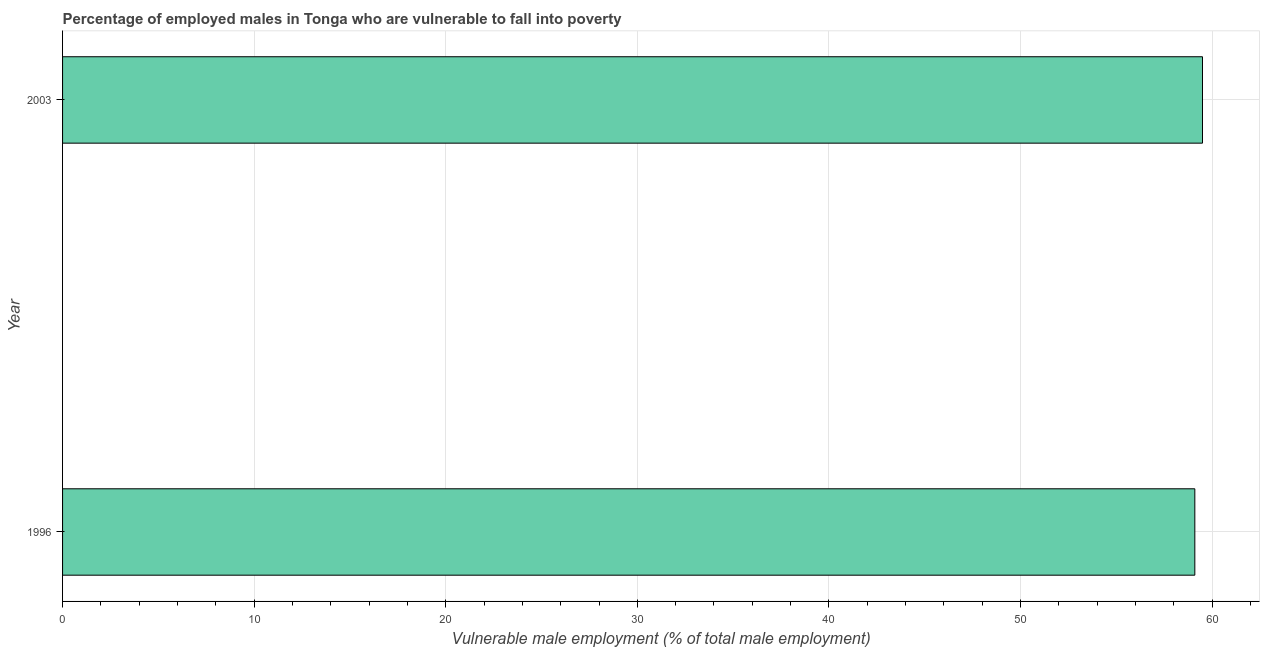Does the graph contain any zero values?
Provide a succinct answer. No. Does the graph contain grids?
Ensure brevity in your answer.  Yes. What is the title of the graph?
Make the answer very short. Percentage of employed males in Tonga who are vulnerable to fall into poverty. What is the label or title of the X-axis?
Offer a terse response. Vulnerable male employment (% of total male employment). What is the percentage of employed males who are vulnerable to fall into poverty in 2003?
Your answer should be compact. 59.5. Across all years, what is the maximum percentage of employed males who are vulnerable to fall into poverty?
Ensure brevity in your answer.  59.5. Across all years, what is the minimum percentage of employed males who are vulnerable to fall into poverty?
Provide a succinct answer. 59.1. In which year was the percentage of employed males who are vulnerable to fall into poverty maximum?
Your response must be concise. 2003. In which year was the percentage of employed males who are vulnerable to fall into poverty minimum?
Make the answer very short. 1996. What is the sum of the percentage of employed males who are vulnerable to fall into poverty?
Your response must be concise. 118.6. What is the difference between the percentage of employed males who are vulnerable to fall into poverty in 1996 and 2003?
Your response must be concise. -0.4. What is the average percentage of employed males who are vulnerable to fall into poverty per year?
Provide a succinct answer. 59.3. What is the median percentage of employed males who are vulnerable to fall into poverty?
Ensure brevity in your answer.  59.3. In how many years, is the percentage of employed males who are vulnerable to fall into poverty greater than 38 %?
Make the answer very short. 2. Do a majority of the years between 2003 and 1996 (inclusive) have percentage of employed males who are vulnerable to fall into poverty greater than 4 %?
Your answer should be compact. No. What is the ratio of the percentage of employed males who are vulnerable to fall into poverty in 1996 to that in 2003?
Your response must be concise. 0.99. In how many years, is the percentage of employed males who are vulnerable to fall into poverty greater than the average percentage of employed males who are vulnerable to fall into poverty taken over all years?
Your response must be concise. 1. Are all the bars in the graph horizontal?
Your response must be concise. Yes. How many years are there in the graph?
Ensure brevity in your answer.  2. What is the Vulnerable male employment (% of total male employment) of 1996?
Provide a succinct answer. 59.1. What is the Vulnerable male employment (% of total male employment) of 2003?
Make the answer very short. 59.5. What is the difference between the Vulnerable male employment (% of total male employment) in 1996 and 2003?
Provide a succinct answer. -0.4. 